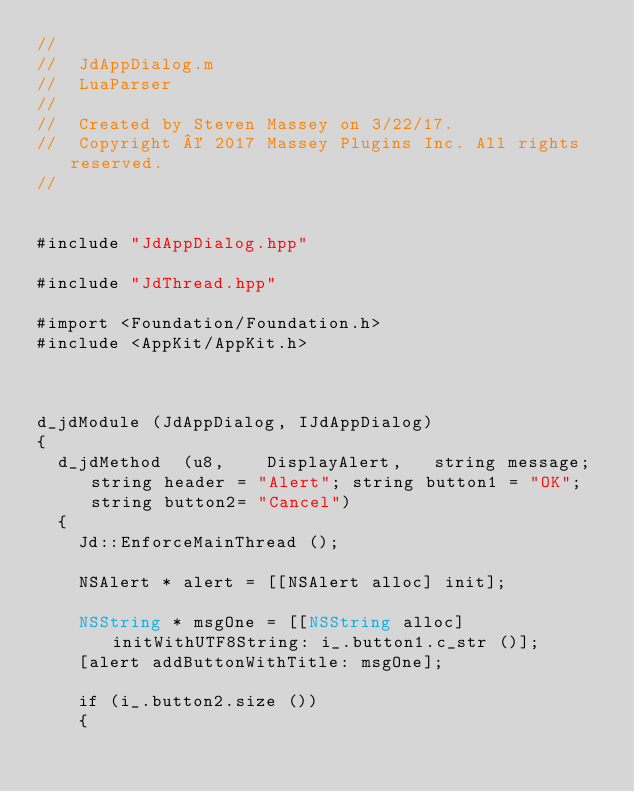<code> <loc_0><loc_0><loc_500><loc_500><_ObjectiveC_>//
//  JdAppDialog.m
//  LuaParser
//
//  Created by Steven Massey on 3/22/17.
//  Copyright © 2017 Massey Plugins Inc. All rights reserved.
//


#include "JdAppDialog.hpp"

#include "JdThread.hpp"

#import <Foundation/Foundation.h>
#include <AppKit/AppKit.h>



d_jdModule (JdAppDialog, IJdAppDialog)
{
	d_jdMethod	(u8,		DisplayAlert,		string message; string header = "Alert"; string button1 = "OK"; string button2= "Cancel")
	{
		Jd::EnforceMainThread ();
		
		NSAlert * alert = [[NSAlert alloc] init];
		
		NSString * msgOne = [[NSString alloc] initWithUTF8String: i_.button1.c_str ()];
		[alert addButtonWithTitle: msgOne];

		if (i_.button2.size ())
		{</code> 